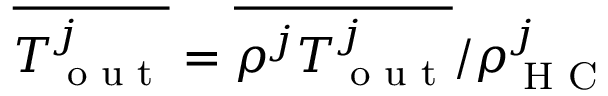Convert formula to latex. <formula><loc_0><loc_0><loc_500><loc_500>\overline { { T _ { o u t } ^ { j } } } = \overline { { \rho ^ { j } T _ { o u t } ^ { j } } } / \rho _ { H C } ^ { j }</formula> 